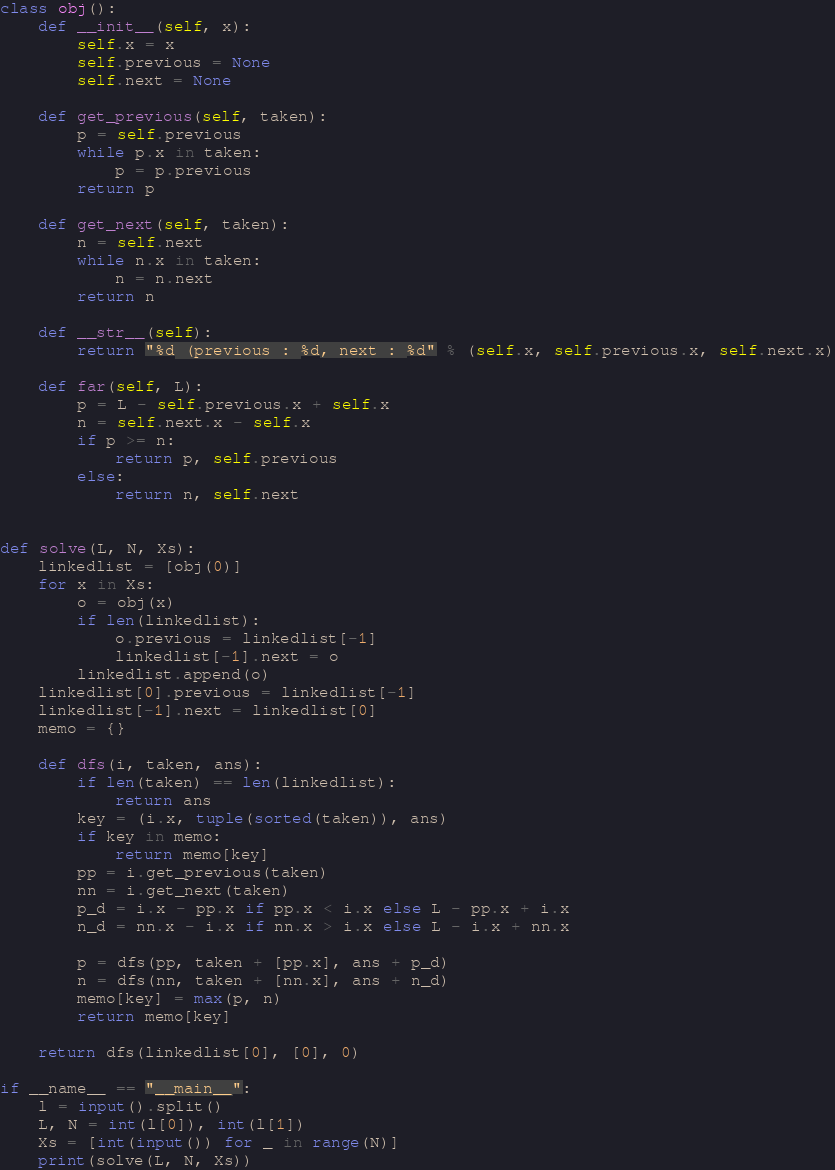Convert code to text. <code><loc_0><loc_0><loc_500><loc_500><_Python_>class obj():
    def __init__(self, x):
        self.x = x
        self.previous = None
        self.next = None

    def get_previous(self, taken):
        p = self.previous
        while p.x in taken:
            p = p.previous
        return p

    def get_next(self, taken):
        n = self.next
        while n.x in taken:
            n = n.next
        return n

    def __str__(self):
        return "%d (previous : %d, next : %d" % (self.x, self.previous.x, self.next.x)

    def far(self, L):
        p = L - self.previous.x + self.x
        n = self.next.x - self.x
        if p >= n:
            return p, self.previous
        else:
            return n, self.next


def solve(L, N, Xs):
    linkedlist = [obj(0)]
    for x in Xs:
        o = obj(x)
        if len(linkedlist):
            o.previous = linkedlist[-1]
            linkedlist[-1].next = o
        linkedlist.append(o)
    linkedlist[0].previous = linkedlist[-1]
    linkedlist[-1].next = linkedlist[0]
    memo = {}

    def dfs(i, taken, ans):
        if len(taken) == len(linkedlist):
            return ans
        key = (i.x, tuple(sorted(taken)), ans)
        if key in memo:
            return memo[key]
        pp = i.get_previous(taken)
        nn = i.get_next(taken)
        p_d = i.x - pp.x if pp.x < i.x else L - pp.x + i.x
        n_d = nn.x - i.x if nn.x > i.x else L - i.x + nn.x

        p = dfs(pp, taken + [pp.x], ans + p_d)
        n = dfs(nn, taken + [nn.x], ans + n_d)
        memo[key] = max(p, n)
        return memo[key]

    return dfs(linkedlist[0], [0], 0)

if __name__ == "__main__":
    l = input().split()
    L, N = int(l[0]), int(l[1])
    Xs = [int(input()) for _ in range(N)]
    print(solve(L, N, Xs))
</code> 